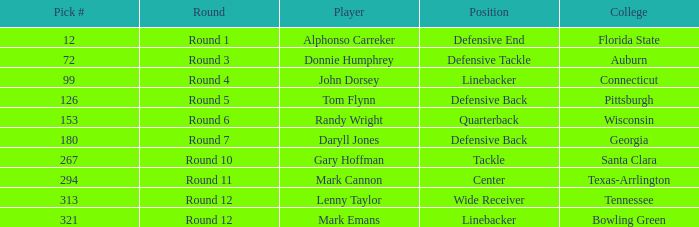In what Round was Pick #12 drafted? Round 1. 